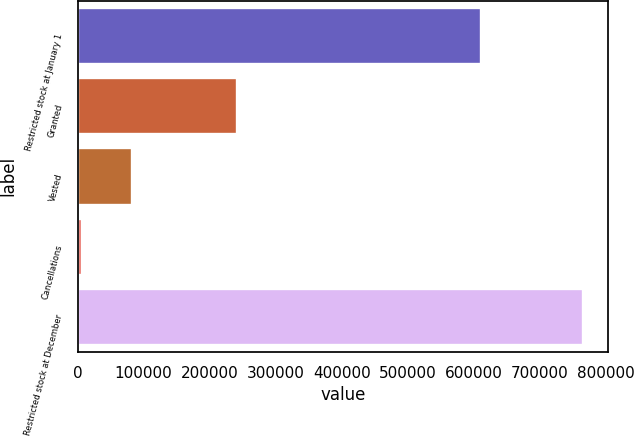<chart> <loc_0><loc_0><loc_500><loc_500><bar_chart><fcel>Restricted stock at January 1<fcel>Granted<fcel>Vested<fcel>Cancellations<fcel>Restricted stock at December<nl><fcel>610380<fcel>240920<fcel>81861.5<fcel>5990<fcel>764705<nl></chart> 